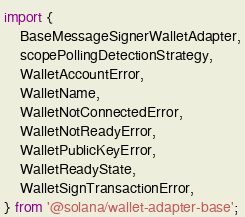Convert code to text. <code><loc_0><loc_0><loc_500><loc_500><_TypeScript_>import {
    BaseMessageSignerWalletAdapter,
    scopePollingDetectionStrategy,
    WalletAccountError,
    WalletName,
    WalletNotConnectedError,
    WalletNotReadyError,
    WalletPublicKeyError,
    WalletReadyState,
    WalletSignTransactionError,
} from '@solana/wallet-adapter-base';</code> 